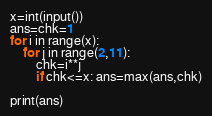Convert code to text. <code><loc_0><loc_0><loc_500><loc_500><_Python_>x=int(input())
ans=chk=1
for i in range(x):
    for j in range(2,11):
        chk=i**j
        if chk<=x: ans=max(ans,chk)
    
print(ans)</code> 